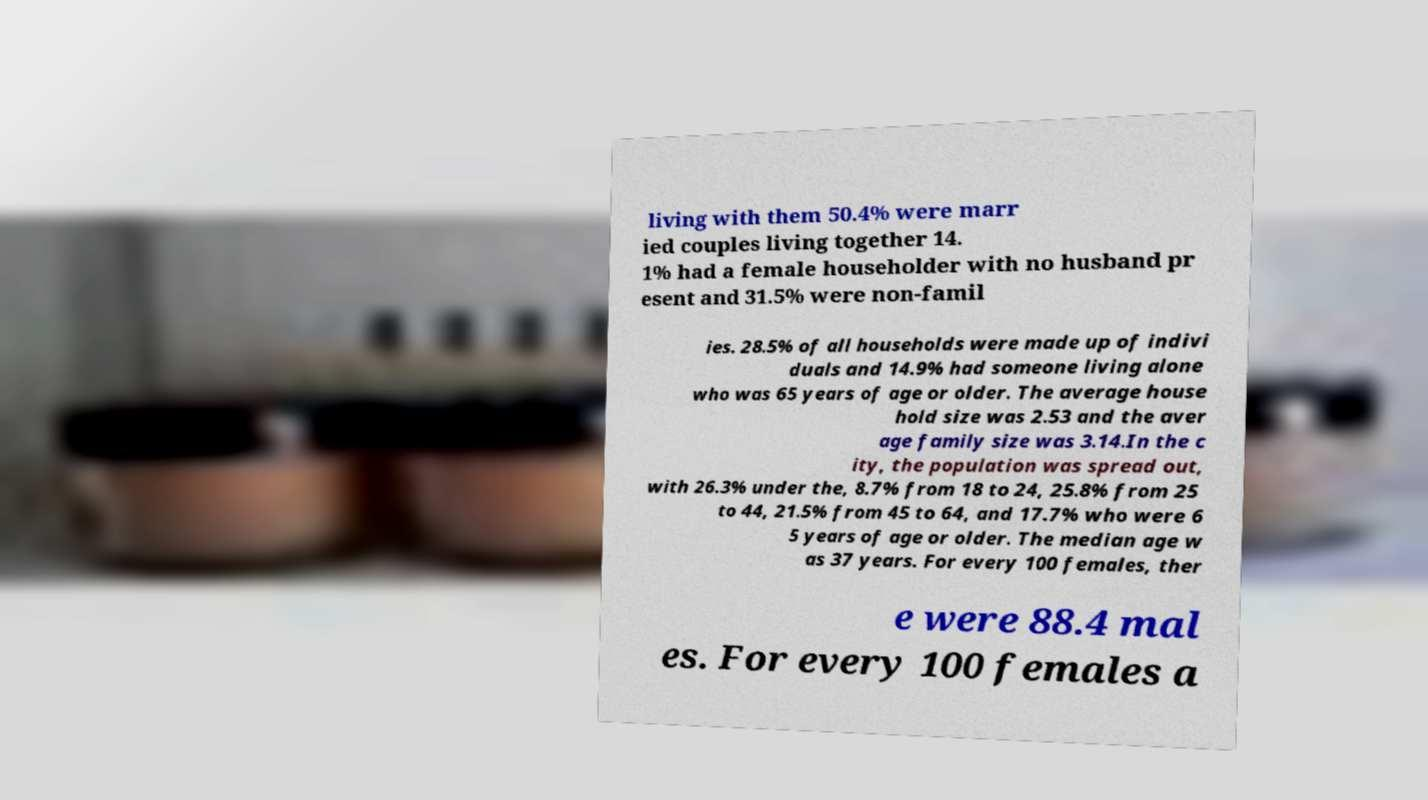What messages or text are displayed in this image? I need them in a readable, typed format. living with them 50.4% were marr ied couples living together 14. 1% had a female householder with no husband pr esent and 31.5% were non-famil ies. 28.5% of all households were made up of indivi duals and 14.9% had someone living alone who was 65 years of age or older. The average house hold size was 2.53 and the aver age family size was 3.14.In the c ity, the population was spread out, with 26.3% under the, 8.7% from 18 to 24, 25.8% from 25 to 44, 21.5% from 45 to 64, and 17.7% who were 6 5 years of age or older. The median age w as 37 years. For every 100 females, ther e were 88.4 mal es. For every 100 females a 